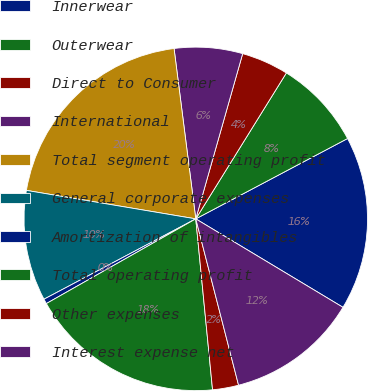Convert chart to OTSL. <chart><loc_0><loc_0><loc_500><loc_500><pie_chart><fcel>Innerwear<fcel>Outerwear<fcel>Direct to Consumer<fcel>International<fcel>Total segment operating profit<fcel>General corporate expenses<fcel>Amortization of intangibles<fcel>Total operating profit<fcel>Other expenses<fcel>Interest expense net<nl><fcel>16.36%<fcel>8.41%<fcel>4.44%<fcel>6.42%<fcel>20.33%<fcel>10.4%<fcel>0.46%<fcel>18.35%<fcel>2.45%<fcel>12.38%<nl></chart> 